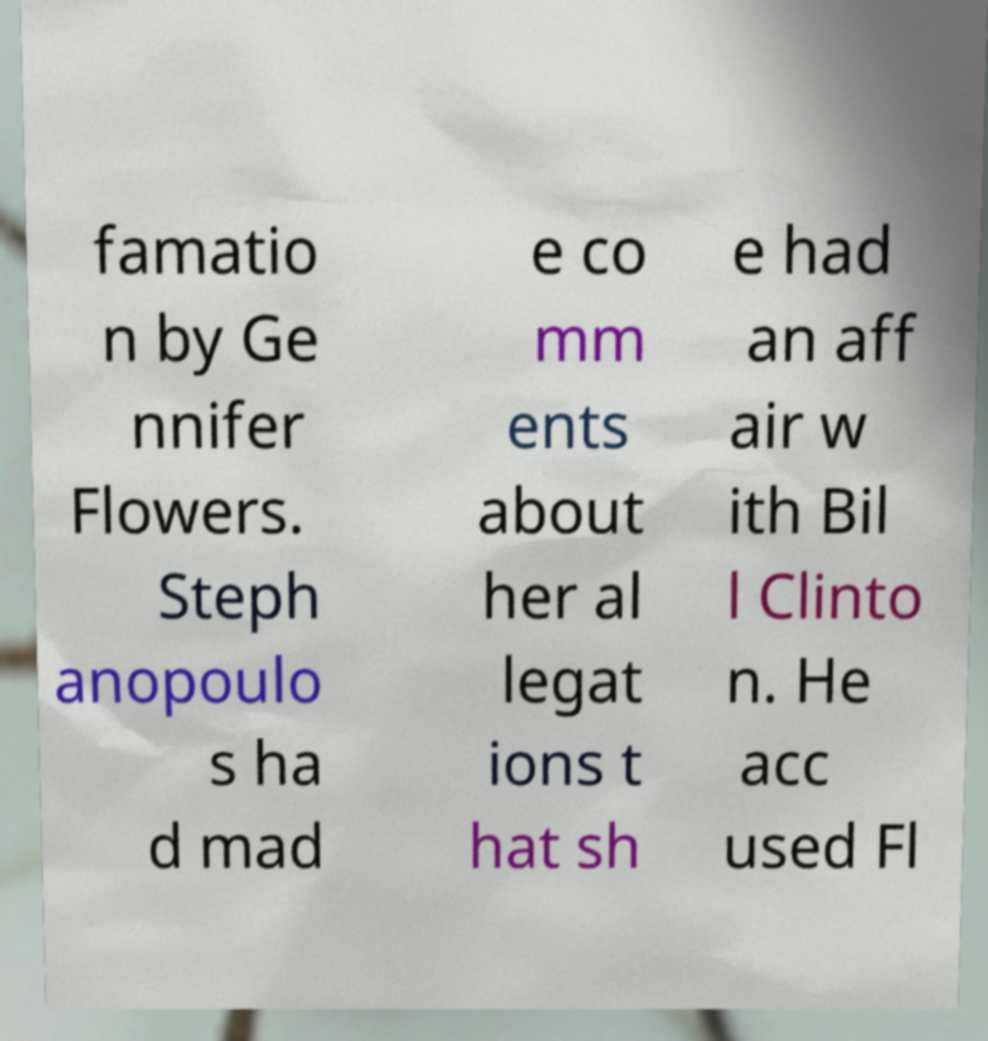Can you read and provide the text displayed in the image?This photo seems to have some interesting text. Can you extract and type it out for me? famatio n by Ge nnifer Flowers. Steph anopoulo s ha d mad e co mm ents about her al legat ions t hat sh e had an aff air w ith Bil l Clinto n. He acc used Fl 